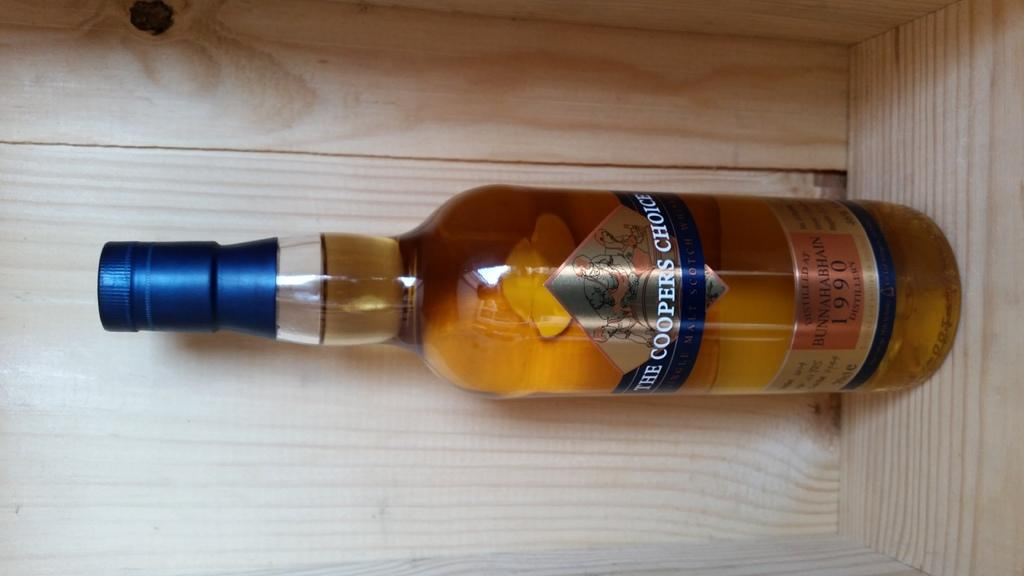What is contained within the bottle in the image? There is a full drink in the bottle. Can you describe the contents of the bottle? The bottle contains a full drink. What type of station can be seen in the background of the image? There is no station present in the image; it only features a bottle with a full drink in it. What kind of agreement is being made between the cloud and the bottle in the image? There is no cloud or agreement present in the image; it only features a bottle with a full drink in it. 